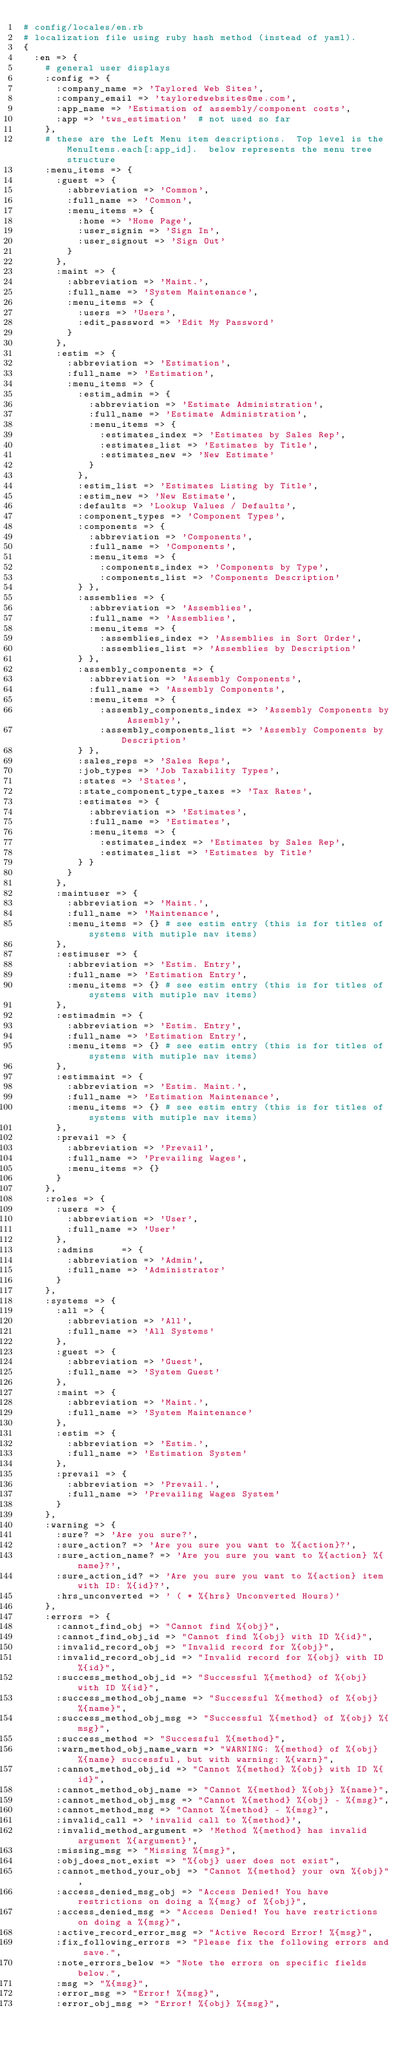<code> <loc_0><loc_0><loc_500><loc_500><_Ruby_># config/locales/en.rb
# localization file using ruby hash method (instead of yaml).
{
  :en => {
    # general user displays
    :config => {
      :company_name => 'Taylored Web Sites',
      :company_email => 'tayloredwebsites@me.com',
      :app_name => 'Estimation of assembly/component costs',
      :app => 'tws_estimation'  # not used so far
    },
    # these are the Left Menu item descriptions.  Top level is the MenuItems.each[:app_id].  below represents the menu tree structure
    :menu_items => {
      :guest => {
        :abbreviation => 'Common',
        :full_name => 'Common',
        :menu_items => {
          :home => 'Home Page',
          :user_signin => 'Sign In',
          :user_signout => 'Sign Out'
        }
      },
      :maint => {
        :abbreviation => 'Maint.',
        :full_name => 'System Maintenance',
        :menu_items => {
          :users => 'Users',
          :edit_password => 'Edit My Password'
        }
      },
      :estim => {
        :abbreviation => 'Estimation',
        :full_name => 'Estimation',
        :menu_items => {
          :estim_admin => {
            :abbreviation => 'Estimate Administration',
            :full_name => 'Estimate Administration',
            :menu_items => {
              :estimates_index => 'Estimates by Sales Rep',
              :estimates_list => 'Estimates by Title',
              :estimates_new => 'New Estimate'
            }
          },
          :estim_list => 'Estimates Listing by Title',
          :estim_new => 'New Estimate',
          :defaults => 'Lookup Values / Defaults',
          :component_types => 'Component Types',
          :components => {
            :abbreviation => 'Components',
            :full_name => 'Components',
            :menu_items => {
              :components_index => 'Components by Type',
              :components_list => 'Components Description'
          } },
          :assemblies => {
            :abbreviation => 'Assemblies',
            :full_name => 'Assemblies',
            :menu_items => {
              :assemblies_index => 'Assemblies in Sort Order',
              :assemblies_list => 'Assemblies by Description'
          } },
          :assembly_components => {
            :abbreviation => 'Assembly Components',
            :full_name => 'Assembly Components',
            :menu_items => {
              :assembly_components_index => 'Assembly Components by Assembly',
              :assembly_components_list => 'Assembly Components by Description'
          } },
          :sales_reps => 'Sales Reps',
          :job_types => 'Job Taxability Types',
          :states => 'States',
          :state_component_type_taxes => 'Tax Rates',
          :estimates => {
            :abbreviation => 'Estimates',
            :full_name => 'Estimates',
            :menu_items => {
              :estimates_index => 'Estimates by Sales Rep',
              :estimates_list => 'Estimates by Title'
          } }
        }
      },
      :maintuser => {
        :abbreviation => 'Maint.',
        :full_name => 'Maintenance',
        :menu_items => {} # see estim entry (this is for titles of systems with mutiple nav items)
      },
      :estimuser => {
        :abbreviation => 'Estim. Entry',
        :full_name => 'Estimation Entry',
        :menu_items => {} # see estim entry (this is for titles of systems with mutiple nav items)
      },
      :estimadmin => {
        :abbreviation => 'Estim. Entry',
        :full_name => 'Estimation Entry',
        :menu_items => {} # see estim entry (this is for titles of systems with mutiple nav items)
      },
      :estimmaint => {
        :abbreviation => 'Estim. Maint.',
        :full_name => 'Estimation Maintenance',
        :menu_items => {} # see estim entry (this is for titles of systems with mutiple nav items)
      },
      :prevail => {
        :abbreviation => 'Prevail',
        :full_name => 'Prevailing Wages',
        :menu_items => {}
      }
    },
    :roles => {
      :users => {
        :abbreviation => 'User',
        :full_name => 'User'
      },
      :admins     => {
        :abbreviation => 'Admin',
        :full_name => 'Administrator'
      }
    },
    :systems => {
      :all => {
        :abbreviation => 'All',
        :full_name => 'All Systems'
      },
      :guest => {
        :abbreviation => 'Guest',
        :full_name => 'System Guest'
      },
      :maint => {
        :abbreviation => 'Maint.',
        :full_name => 'System Maintenance'
      },
      :estim => {
        :abbreviation => 'Estim.',
        :full_name => 'Estimation System'
      },
      :prevail => {
        :abbreviation => 'Prevail.',
        :full_name => 'Prevailing Wages System'
      }
    },
    :warning => {
      :sure? => 'Are you sure?',
      :sure_action? => 'Are you sure you want to %{action}?',
      :sure_action_name? => 'Are you sure you want to %{action} %{name}?',
      :sure_action_id? => 'Are you sure you want to %{action} item with ID: %{id}?',
      :hrs_unconverted => ' ( * %{hrs} Unconverted Hours)'
    },
    :errors => {
      :cannot_find_obj => "Cannot find %{obj}",
      :cannot_find_obj_id => "Cannot find %{obj} with ID %{id}",
      :invalid_record_obj => "Invalid record for %{obj}",
      :invalid_record_obj_id => "Invalid record for %{obj} with ID %{id}",
      :success_method_obj_id => "Successful %{method} of %{obj} with ID %{id}",
      :success_method_obj_name => "Successful %{method} of %{obj} %{name}",
      :success_method_obj_msg => "Successful %{method} of %{obj} %{msg}",
      :success_method => "Successful %{method}",
      :warn_method_obj_name_warn => "WARNING: %{method} of %{obj} %{name} successful, but with warning: %{warn}",
      :cannot_method_obj_id => "Cannot %{method} %{obj} with ID %{id}",
      :cannot_method_obj_name => "Cannot %{method} %{obj} %{name}",
      :cannot_method_obj_msg => "Cannot %{method} %{obj} - %{msg}",
      :cannot_method_msg => "Cannot %{method} - %{msg}",
      :invalid_call => 'invalid call to %{method}',
      :invalid_method_argument => 'Method %{method} has invalid argument %{argument}',
      :missing_msg => "Missing %{msg}",
      :obj_does_not_exist => "%{obj} user does not exist",
      :cannot_method_your_obj => "Cannot %{method} your own %{obj}",
      :access_denied_msg_obj => "Access Denied! You have restrictions on doing a %{msg} of %{obj}",
      :access_denied_msg => "Access Denied! You have restrictions on doing a %{msg}",
      :active_record_error_msg => "Active Record Error! %{msg}",
      :fix_following_errors => "Please fix the following errors and save.",
      :note_errors_below => "Note the errors on specific fields below.",
      :msg => "%{msg}",
      :error_msg => "Error! %{msg}",
      :error_obj_msg => "Error! %{obj} %{msg}",</code> 